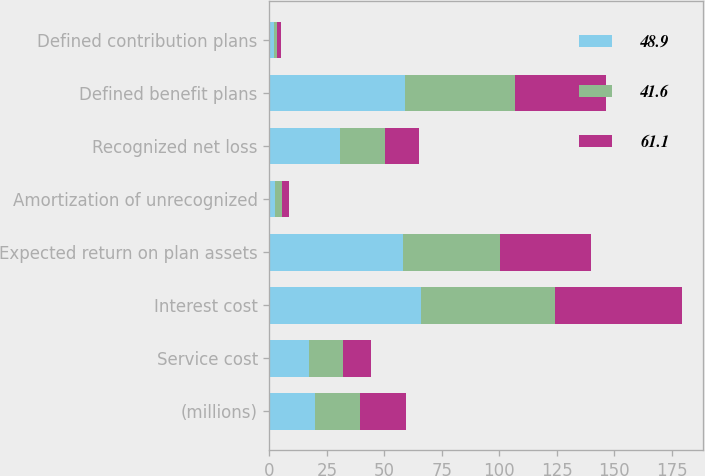<chart> <loc_0><loc_0><loc_500><loc_500><stacked_bar_chart><ecel><fcel>(millions)<fcel>Service cost<fcel>Interest cost<fcel>Expected return on plan assets<fcel>Amortization of unrecognized<fcel>Recognized net loss<fcel>Defined benefit plans<fcel>Defined contribution plans<nl><fcel>48.9<fcel>19.8<fcel>17.4<fcel>65.8<fcel>58.2<fcel>2.6<fcel>30.6<fcel>59.2<fcel>1.9<nl><fcel>41.6<fcel>19.8<fcel>14.5<fcel>58.3<fcel>42.1<fcel>2.9<fcel>19.8<fcel>47.6<fcel>1.3<nl><fcel>61.1<fcel>19.8<fcel>12.1<fcel>55.6<fcel>39.8<fcel>2.9<fcel>14.8<fcel>39.8<fcel>1.8<nl></chart> 